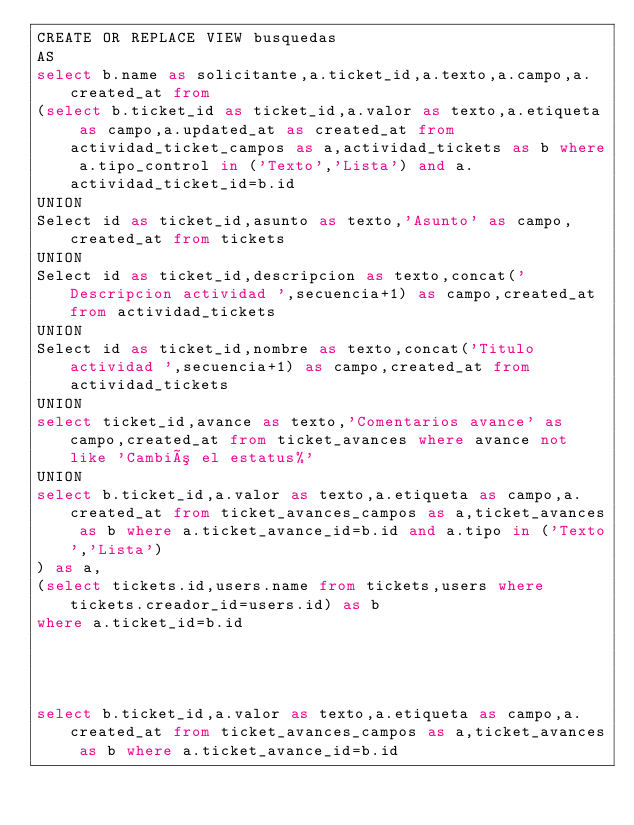Convert code to text. <code><loc_0><loc_0><loc_500><loc_500><_SQL_>CREATE OR REPLACE VIEW busquedas
AS 
select b.name as solicitante,a.ticket_id,a.texto,a.campo,a.created_at from 
(select b.ticket_id as ticket_id,a.valor as texto,a.etiqueta as campo,a.updated_at as created_at from actividad_ticket_campos as a,actividad_tickets as b where a.tipo_control in ('Texto','Lista') and a.actividad_ticket_id=b.id
UNION
Select id as ticket_id,asunto as texto,'Asunto' as campo,created_at from tickets
UNION
Select id as ticket_id,descripcion as texto,concat('Descripcion actividad ',secuencia+1) as campo,created_at from actividad_tickets
UNION
Select id as ticket_id,nombre as texto,concat('Titulo actividad ',secuencia+1) as campo,created_at from actividad_tickets
UNION
select ticket_id,avance as texto,'Comentarios avance' as campo,created_at from ticket_avances where avance not like 'Cambió el estatus%'
UNION
select b.ticket_id,a.valor as texto,a.etiqueta as campo,a.created_at from ticket_avances_campos as a,ticket_avances as b where a.ticket_avance_id=b.id and a.tipo in ('Texto','Lista')
) as a,
(select tickets.id,users.name from tickets,users where tickets.creador_id=users.id) as b
where a.ticket_id=b.id




select b.ticket_id,a.valor as texto,a.etiqueta as campo,a.created_at from ticket_avances_campos as a,ticket_avances as b where a.ticket_avance_id=b.id</code> 